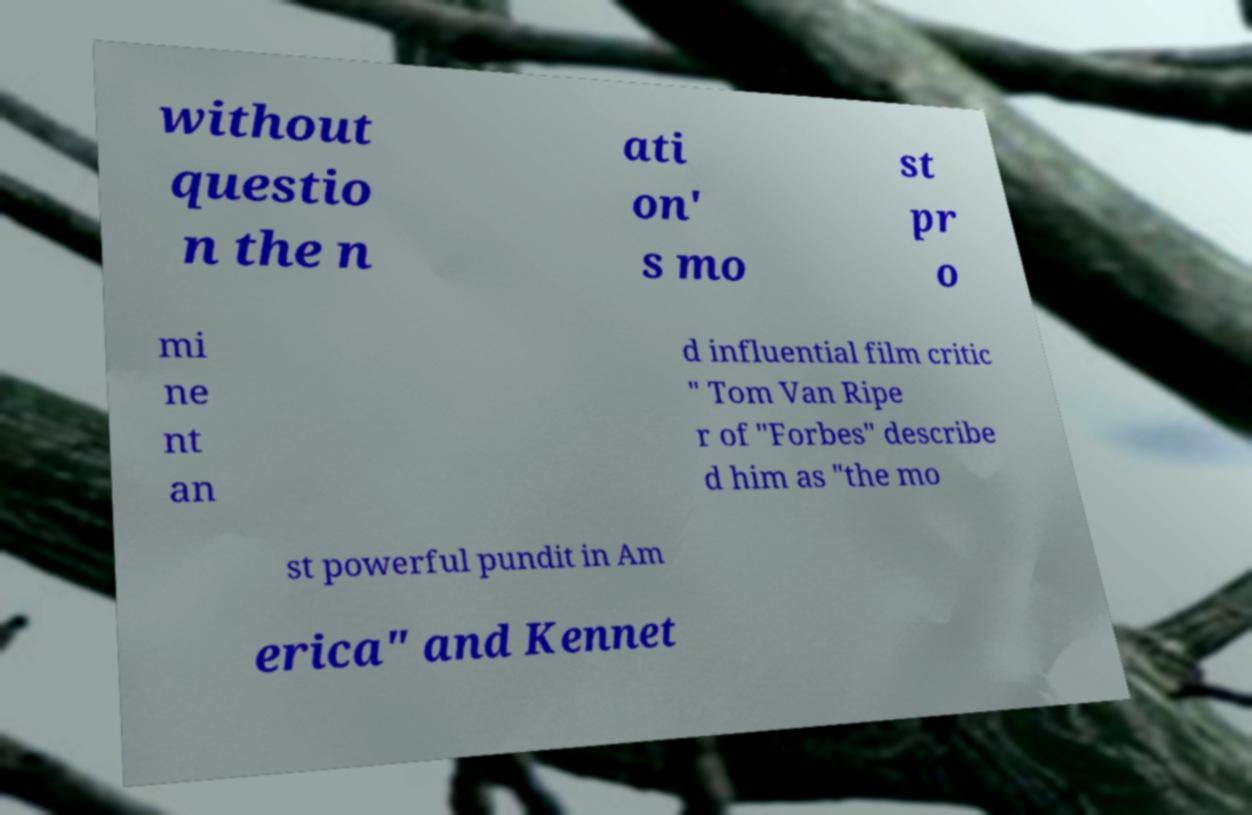There's text embedded in this image that I need extracted. Can you transcribe it verbatim? without questio n the n ati on' s mo st pr o mi ne nt an d influential film critic " Tom Van Ripe r of "Forbes" describe d him as "the mo st powerful pundit in Am erica" and Kennet 